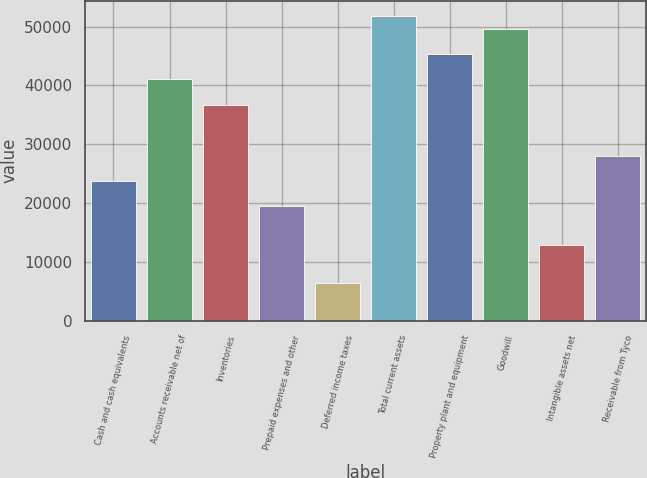Convert chart to OTSL. <chart><loc_0><loc_0><loc_500><loc_500><bar_chart><fcel>Cash and cash equivalents<fcel>Accounts receivable net of<fcel>Inventories<fcel>Prepaid expenses and other<fcel>Deferred income taxes<fcel>Total current assets<fcel>Property plant and equipment<fcel>Goodwill<fcel>Intangible assets net<fcel>Receivable from Tyco<nl><fcel>23759<fcel>41031<fcel>36713<fcel>19441<fcel>6487<fcel>51826<fcel>45349<fcel>49667<fcel>12964<fcel>28077<nl></chart> 